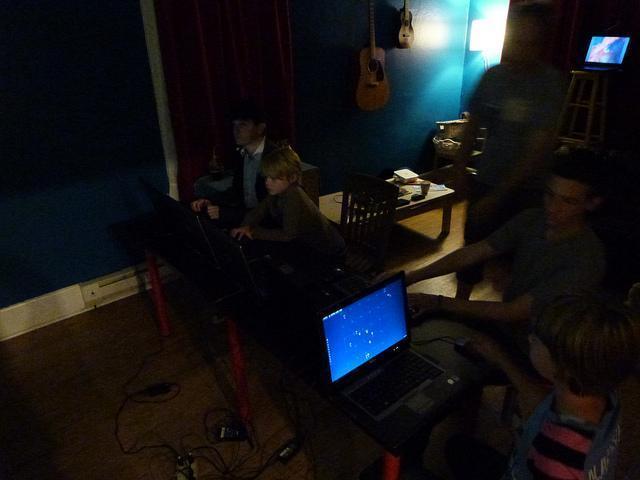How many people can be seen?
Give a very brief answer. 5. How many laptops are visible?
Give a very brief answer. 2. How many cars are waiting at the light?
Give a very brief answer. 0. 